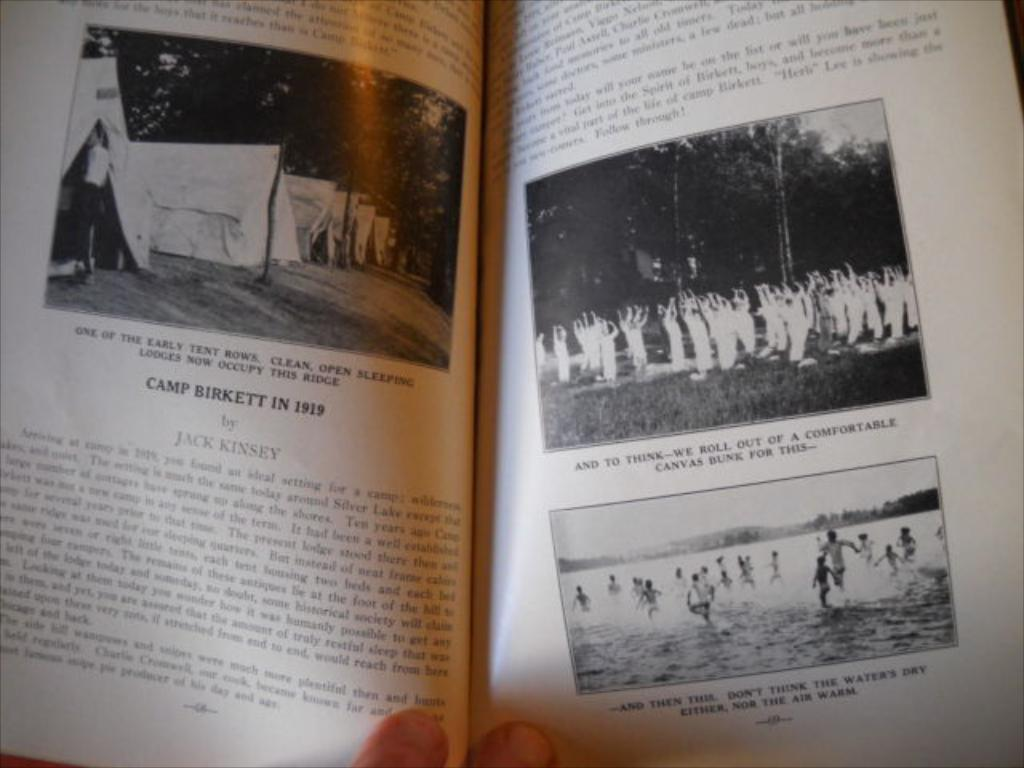<image>
Give a short and clear explanation of the subsequent image. A biographical look at Camp Birkett in the year nineteen nineteen. 